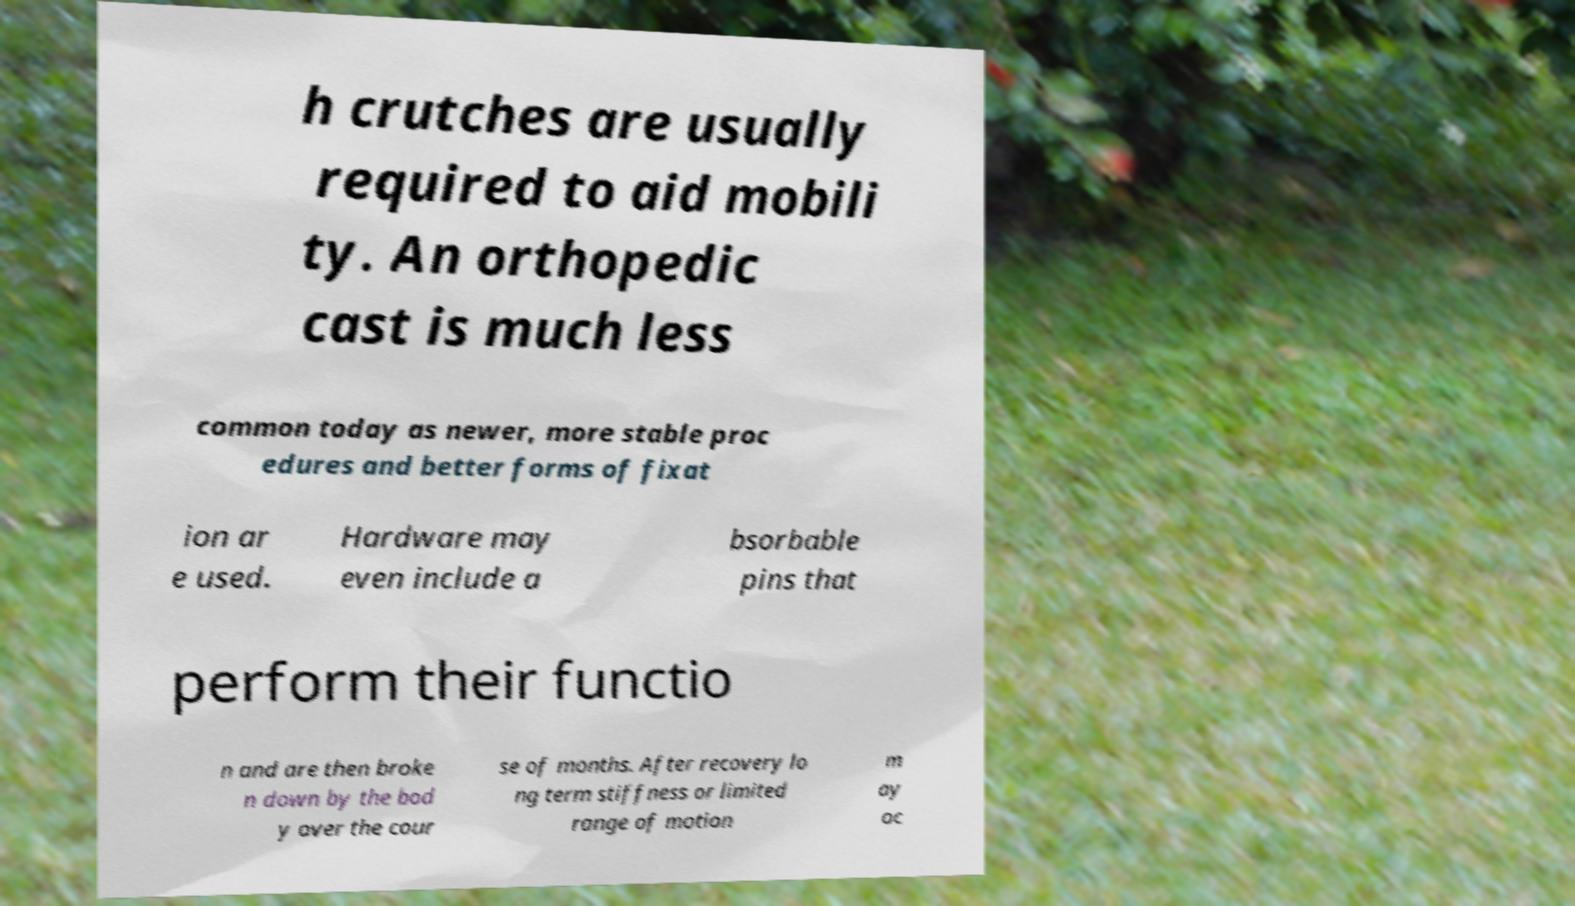Could you extract and type out the text from this image? h crutches are usually required to aid mobili ty. An orthopedic cast is much less common today as newer, more stable proc edures and better forms of fixat ion ar e used. Hardware may even include a bsorbable pins that perform their functio n and are then broke n down by the bod y over the cour se of months. After recovery lo ng term stiffness or limited range of motion m ay oc 